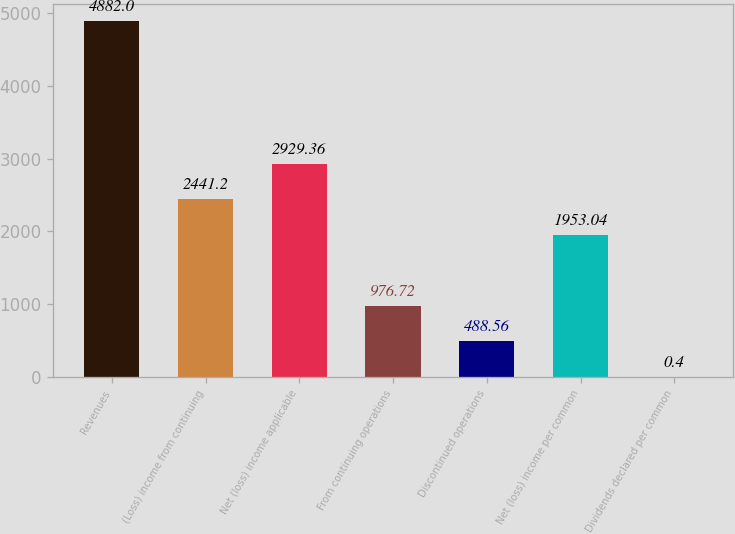Convert chart to OTSL. <chart><loc_0><loc_0><loc_500><loc_500><bar_chart><fcel>Revenues<fcel>(Loss) income from continuing<fcel>Net (loss) income applicable<fcel>From continuing operations<fcel>Discontinued operations<fcel>Net (loss) income per common<fcel>Dividends declared per common<nl><fcel>4882<fcel>2441.2<fcel>2929.36<fcel>976.72<fcel>488.56<fcel>1953.04<fcel>0.4<nl></chart> 